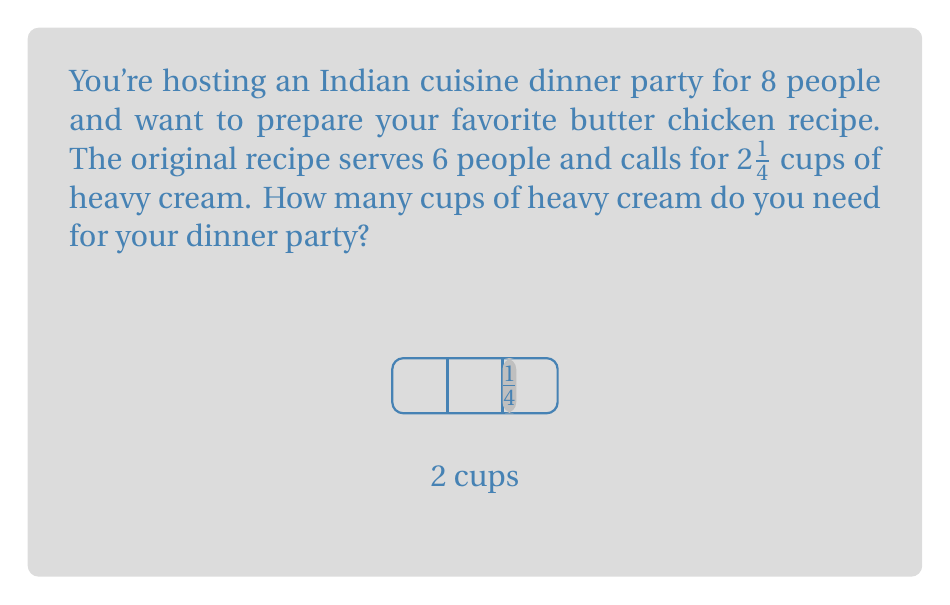Teach me how to tackle this problem. Let's approach this step-by-step:

1) First, we need to find the scaling factor to adjust the recipe from 6 to 8 servings:
   $\frac{8 \text{ servings}}{6 \text{ servings}} = \frac{4}{3}$

2) Now, we need to multiply the original amount of heavy cream by this scaling factor:
   $2\frac{1}{4} \times \frac{4}{3}$

3) To multiply a mixed number by a fraction, we first convert the mixed number to an improper fraction:
   $2\frac{1}{4} = \frac{9}{4}$

4) Now we can multiply the fractions:
   $\frac{9}{4} \times \frac{4}{3} = \frac{36}{12} = 3$

5) Therefore, we need 3 cups of heavy cream for the scaled-up recipe.
Answer: 3 cups 